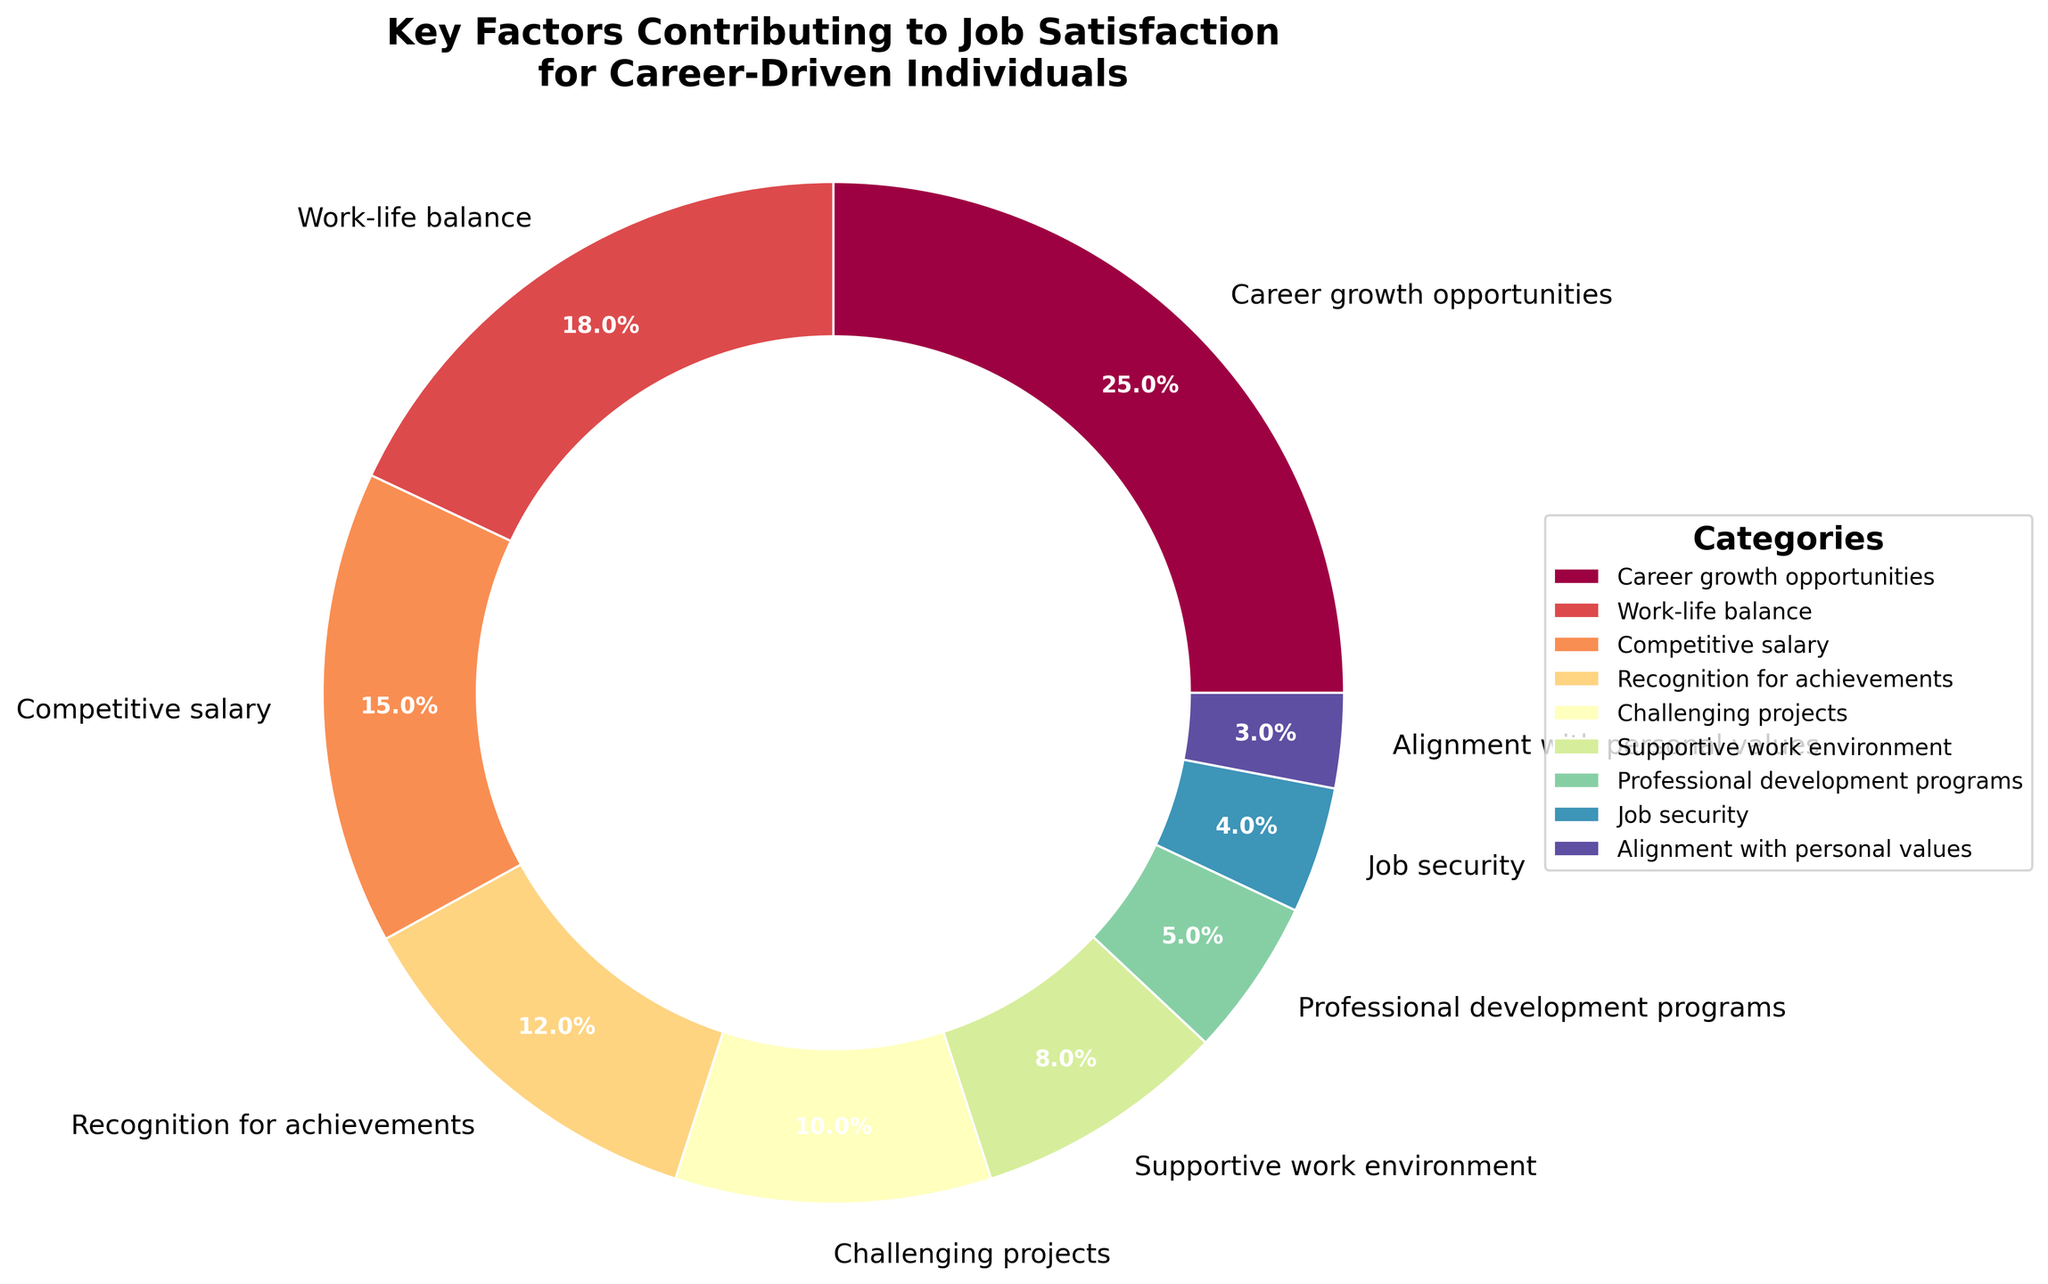What category has the highest percentage in contributing to job satisfaction? By observing the pie chart, the largest segment represents the highest percentage. We identify the segment labeled "Career growth opportunities" that occupies the largest area compared to others.
Answer: Career growth opportunities What is the combined percentage of Work-life balance and Competitive salary? We add the percentages for both Work-life balance (18%) and Competitive salary (15%). Thus, the combined percentage is 18% + 15% = 33%.
Answer: 33% Which category has a higher percentage: Job security or Alignment with personal values? By comparing the respective segments, the pie chart shows Job security with 4% and Alignment with personal values with 3%. Since 4% is greater than 3%, Job security has a higher percentage.
Answer: Job security What are the two categories contributing the least to job satisfaction? The pie chart segments reveal the smallest areas represent the least contributions. These are labeled "Alignment with personal values" at 3% and "Job security" at 4%.
Answer: Alignment with personal values and Job security How much more does Recognition for achievements contribute than Challenging projects? From the pie chart, Recognition for achievements contributes 12% and Challenging projects contribute 10%. To find the difference: 12% - 10% = 2%.
Answer: 2% What is the total percentage of all categories contributing to job satisfaction? Sum the percentages of all categories: 25% + 18% + 15% + 12% + 10% + 8% + 5% + 4% + 3% = 100%.
Answer: 100% How does the percentage contribution of Supportive work environment compare to Professional development programs? The pie chart shows Supportive work environment at 8% and Professional development programs at 5%. 8% is higher than 5%.
Answer: Supportive work environment What color represents the category "Career growth opportunities"? The segment "Career growth opportunities" is highlighted in the pie chart in a specific color from the gradient used. Assuming a typical gradient scheme, it often starts from the top segment and follows through spectrally to the bottom. We identify the specific color from this position in the chart.
Answer: Color from the top segment (assuming a gradient start position) Which categories together account for more than half the total percentage? We identify which combination of categories sum to greater than 50%. By adding:
25% (Career growth opportunities) + 18% (Work-life balance) = 43%,
43% + 15% (Competitive salary) = 58%.
Answer: Career growth opportunities, Work-life balance, and Competitive salary 